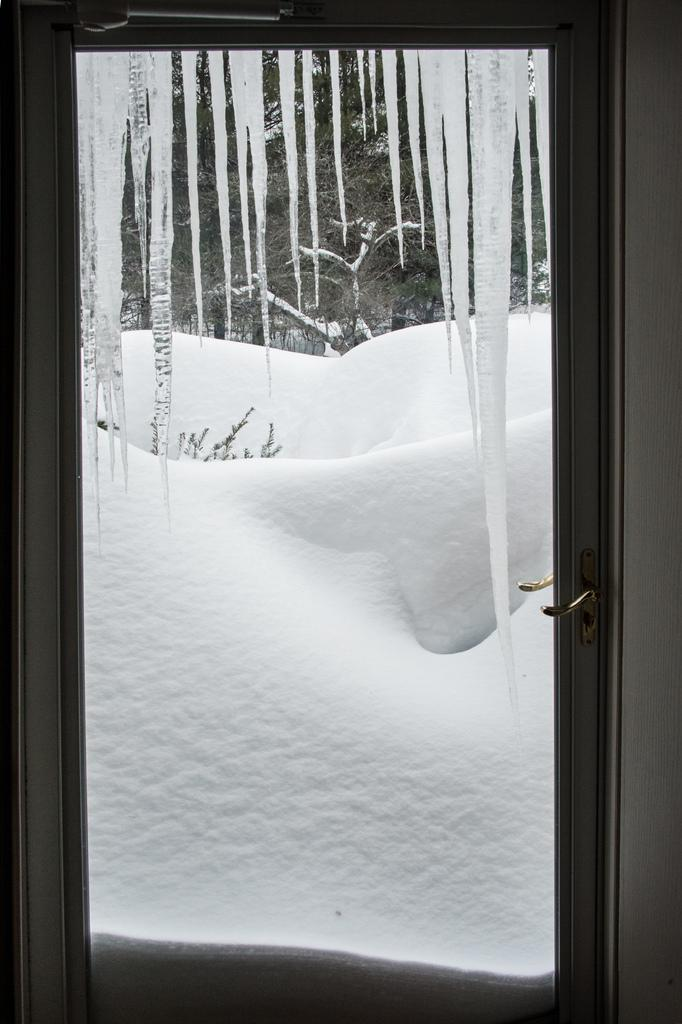What can be seen in the image that provides a view of the outside? There is a window in the image. What is the weather like in the image? Snow is visible in the background of the image, indicating a snowy or wintry scene. What type of vegetation is present in the background of the image? There are plants in the background of the image. What type of key is used to unlock the door in the image? There is no door or key present in the image; it only features a window, snow, and plants in the background. What word is written on the popcorn in the image? There is no popcorn or writing present in the image. 